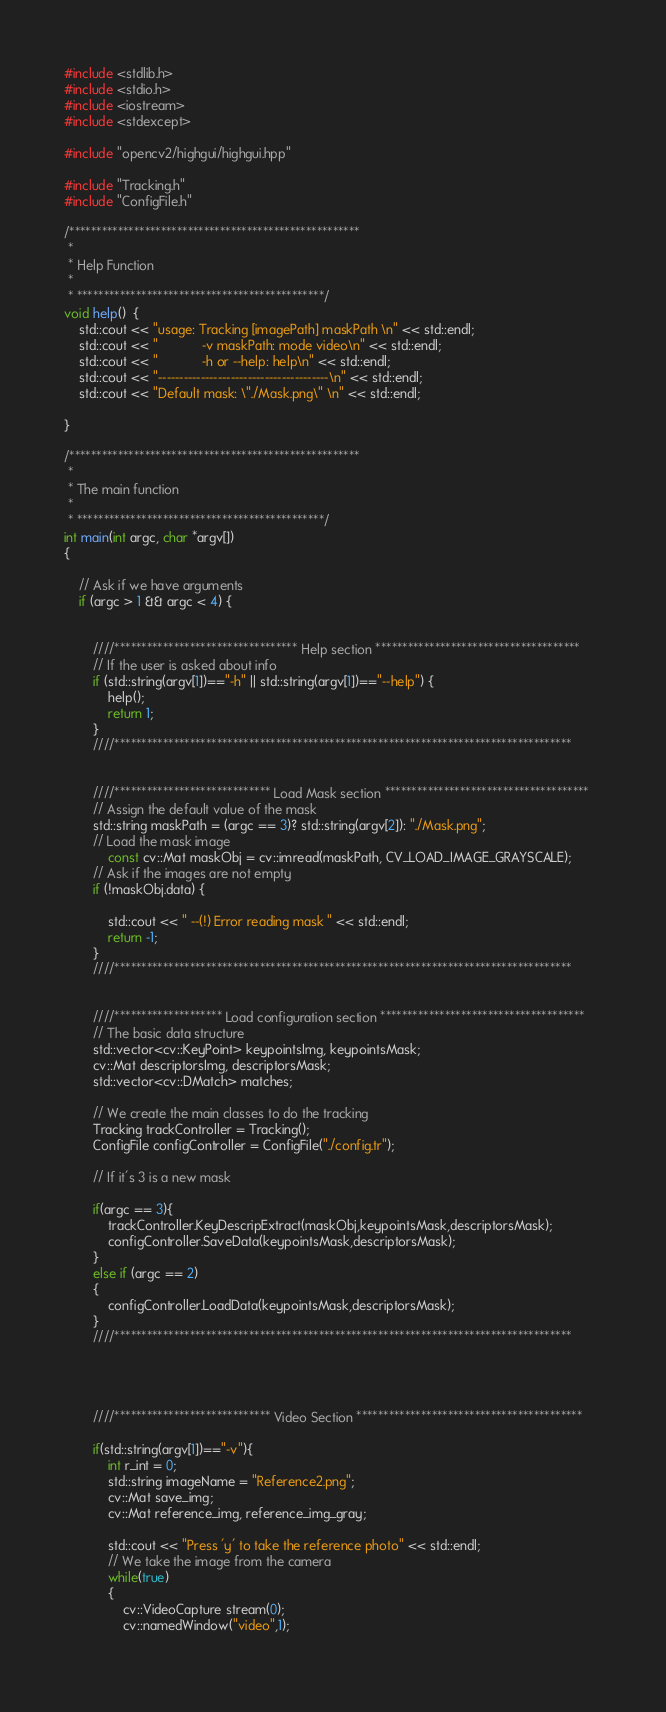<code> <loc_0><loc_0><loc_500><loc_500><_C++_>#include <stdlib.h>
#include <stdio.h>
#include <iostream>
#include <stdexcept>

#include "opencv2/highgui/highgui.hpp"

#include "Tracking.h"
#include "ConfigFile.h"

/******************************************************
 * 
 * Help Function
 * 
 * **********************************************/
void help()  {
	std::cout << "usage: Tracking [imagePath] maskPath \n" << std::endl;
	std::cout << "			-v maskPath: mode video\n" << std::endl;
	std::cout << "			-h or --help: help\n" << std::endl;
	std::cout << "----------------------------------------\n" << std::endl;
	std::cout << "Default mask: \"./Mask.png\" \n" << std::endl;
	
}

/******************************************************
 * 
 * The main function
 * 
 * **********************************************/
int main(int argc, char *argv[])
{

	// Ask if we have arguments
	if (argc > 1 && argc < 4) {


		////********************************** Help section **************************************		
		// If the user is asked about info
		if (std::string(argv[1])=="-h" || std::string(argv[1])=="--help") {
			help();
			return 1;
		}
		////*************************************************************************************


		////***************************** Load Mask section **************************************	
		// Assign the default value of the mask
		std::string maskPath = (argc == 3)? std::string(argv[2]): "./Mask.png";
		// Load the mask image
    		const cv::Mat maskObj = cv::imread(maskPath, CV_LOAD_IMAGE_GRAYSCALE);
		// Ask if the images are not empty
   		if (!maskObj.data) {
		
			std::cout << " --(!) Error reading mask " << std::endl; 
			return -1;
	    }
		////*************************************************************************************


		////******************** Load configuration section **************************************
		// The basic data structure
		std::vector<cv::KeyPoint> keypointsImg, keypointsMask;
 		cv::Mat descriptorsImg, descriptorsMask;
		std::vector<cv::DMatch> matches;

		// We create the main classes to do the tracking
		Tracking trackController = Tracking();
		ConfigFile configController = ConfigFile("./config.tr");

		// If it's 3 is a new mask
		
		if(argc == 3){
			trackController.KeyDescripExtract(maskObj,keypointsMask,descriptorsMask);
			configController.SaveData(keypointsMask,descriptorsMask);
		}
		else if (argc == 2)
		{
			configController.LoadData(keypointsMask,descriptorsMask);
		}
		////*************************************************************************************




		////***************************** Video Section ******************************************

		if(std::string(argv[1])=="-v"){
			int r_int = 0;
			std::string imageName = "Reference2.png";
			cv::Mat save_img;
			cv::Mat reference_img, reference_img_gray;
			
			std::cout << "Press 'y' to take the reference photo" << std::endl;
			// We take the image from the camera
			while(true)
			{				
				cv::VideoCapture stream(0);
    			cv::namedWindow("video",1);
    			</code> 